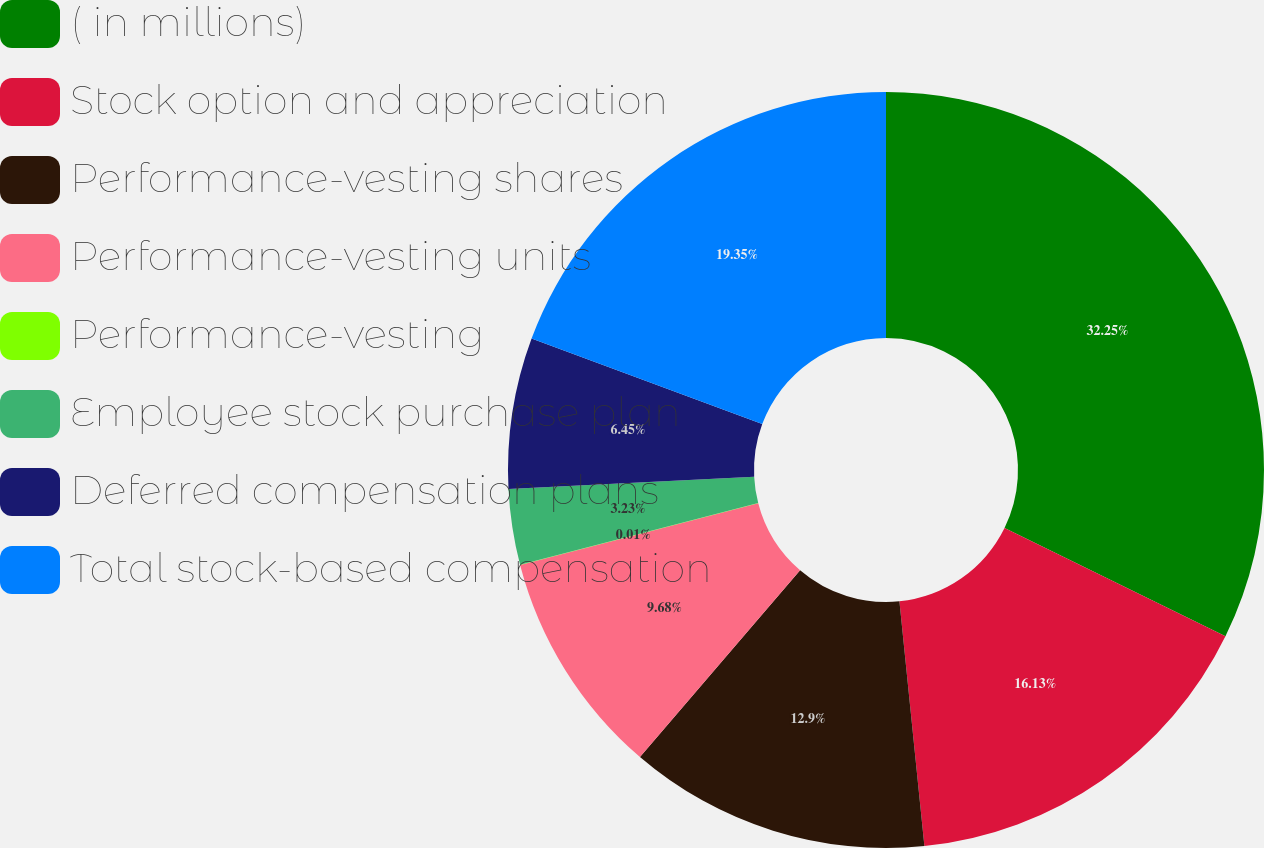<chart> <loc_0><loc_0><loc_500><loc_500><pie_chart><fcel>( in millions)<fcel>Stock option and appreciation<fcel>Performance-vesting shares<fcel>Performance-vesting units<fcel>Performance-vesting<fcel>Employee stock purchase plan<fcel>Deferred compensation plans<fcel>Total stock-based compensation<nl><fcel>32.25%<fcel>16.13%<fcel>12.9%<fcel>9.68%<fcel>0.01%<fcel>3.23%<fcel>6.45%<fcel>19.35%<nl></chart> 